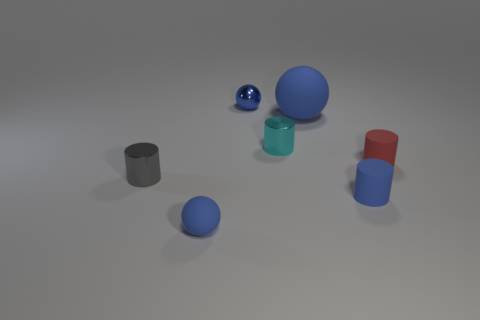How many other objects are there of the same color as the large rubber sphere? 3 